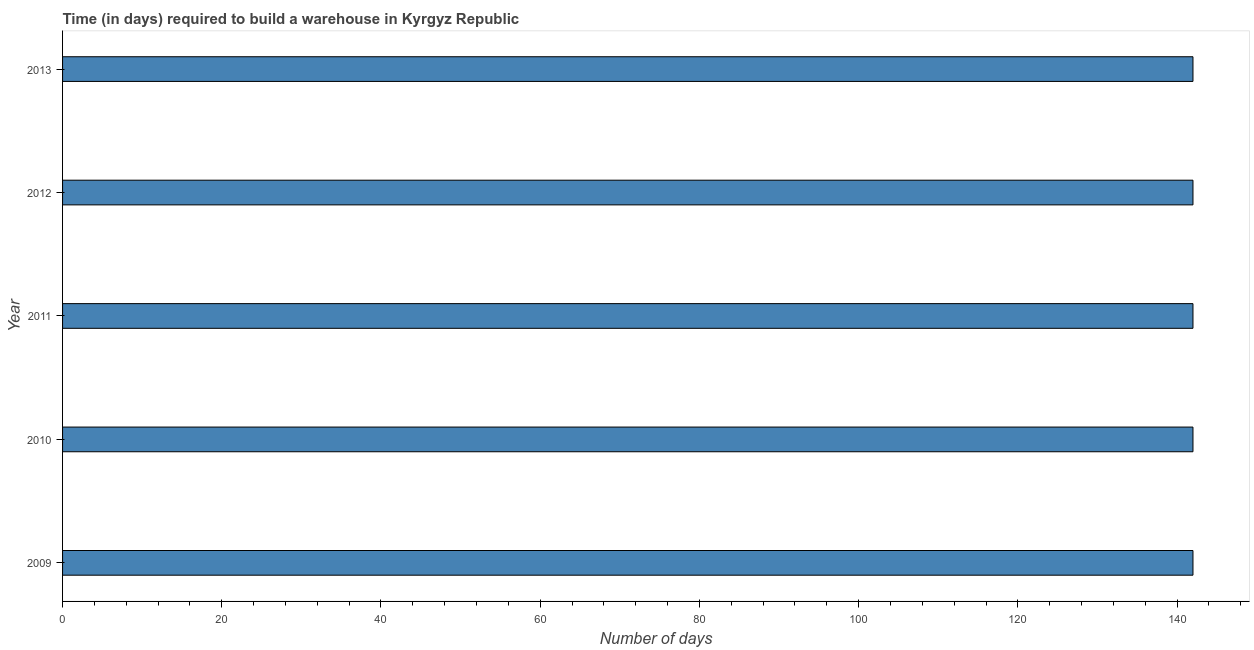Does the graph contain any zero values?
Keep it short and to the point. No. Does the graph contain grids?
Provide a short and direct response. No. What is the title of the graph?
Keep it short and to the point. Time (in days) required to build a warehouse in Kyrgyz Republic. What is the label or title of the X-axis?
Give a very brief answer. Number of days. What is the label or title of the Y-axis?
Offer a very short reply. Year. What is the time required to build a warehouse in 2009?
Your response must be concise. 142. Across all years, what is the maximum time required to build a warehouse?
Ensure brevity in your answer.  142. Across all years, what is the minimum time required to build a warehouse?
Ensure brevity in your answer.  142. In which year was the time required to build a warehouse maximum?
Provide a succinct answer. 2009. In which year was the time required to build a warehouse minimum?
Your response must be concise. 2009. What is the sum of the time required to build a warehouse?
Your answer should be very brief. 710. What is the average time required to build a warehouse per year?
Provide a succinct answer. 142. What is the median time required to build a warehouse?
Offer a terse response. 142. Is the time required to build a warehouse in 2011 less than that in 2013?
Keep it short and to the point. No. In how many years, is the time required to build a warehouse greater than the average time required to build a warehouse taken over all years?
Offer a terse response. 0. Are all the bars in the graph horizontal?
Your answer should be very brief. Yes. How many years are there in the graph?
Provide a succinct answer. 5. What is the Number of days of 2009?
Your response must be concise. 142. What is the Number of days in 2010?
Ensure brevity in your answer.  142. What is the Number of days of 2011?
Provide a short and direct response. 142. What is the Number of days of 2012?
Your response must be concise. 142. What is the Number of days of 2013?
Your answer should be very brief. 142. What is the difference between the Number of days in 2010 and 2011?
Offer a terse response. 0. What is the difference between the Number of days in 2010 and 2012?
Your answer should be compact. 0. What is the difference between the Number of days in 2010 and 2013?
Keep it short and to the point. 0. What is the difference between the Number of days in 2011 and 2013?
Your answer should be compact. 0. What is the ratio of the Number of days in 2009 to that in 2012?
Give a very brief answer. 1. What is the ratio of the Number of days in 2009 to that in 2013?
Offer a terse response. 1. What is the ratio of the Number of days in 2010 to that in 2011?
Ensure brevity in your answer.  1. What is the ratio of the Number of days in 2010 to that in 2013?
Keep it short and to the point. 1. What is the ratio of the Number of days in 2012 to that in 2013?
Provide a succinct answer. 1. 